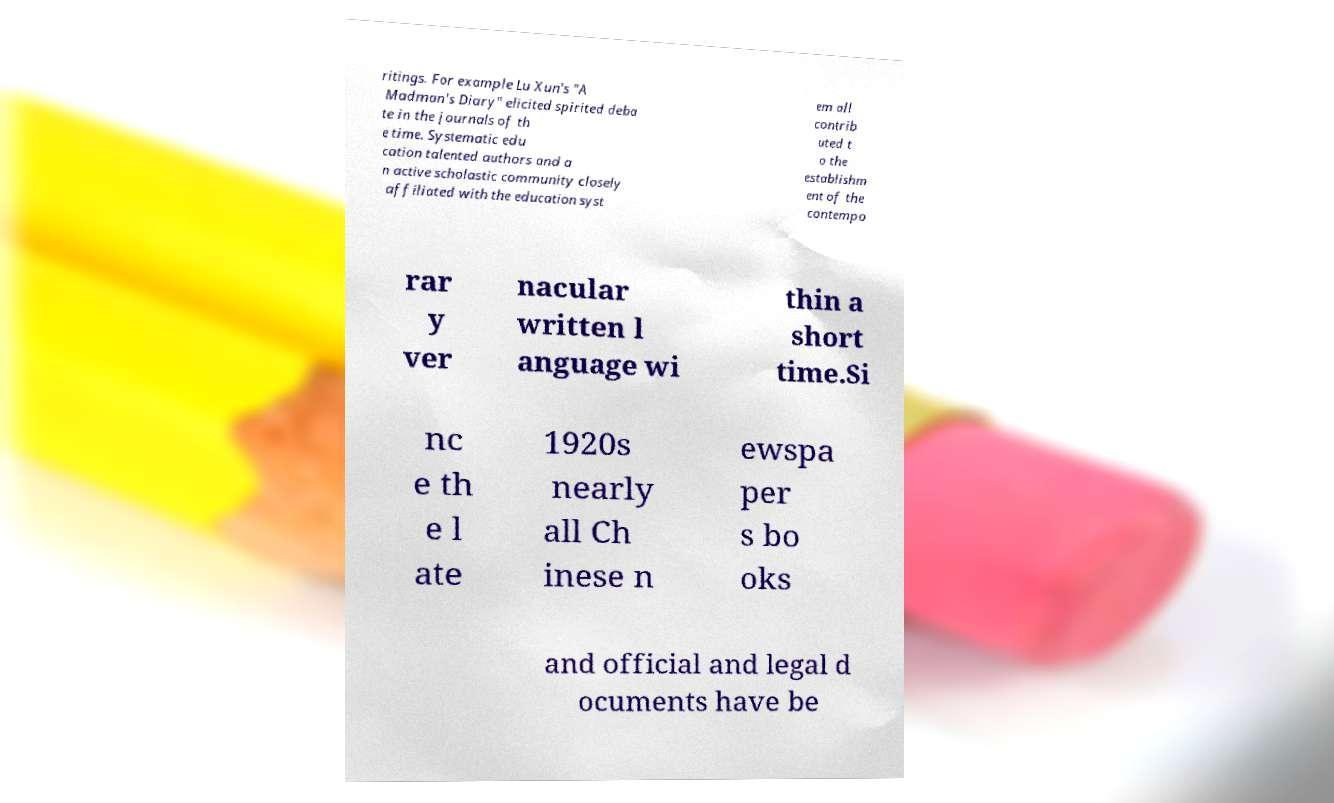Can you read and provide the text displayed in the image?This photo seems to have some interesting text. Can you extract and type it out for me? ritings. For example Lu Xun's "A Madman's Diary" elicited spirited deba te in the journals of th e time. Systematic edu cation talented authors and a n active scholastic community closely affiliated with the education syst em all contrib uted t o the establishm ent of the contempo rar y ver nacular written l anguage wi thin a short time.Si nc e th e l ate 1920s nearly all Ch inese n ewspa per s bo oks and official and legal d ocuments have be 